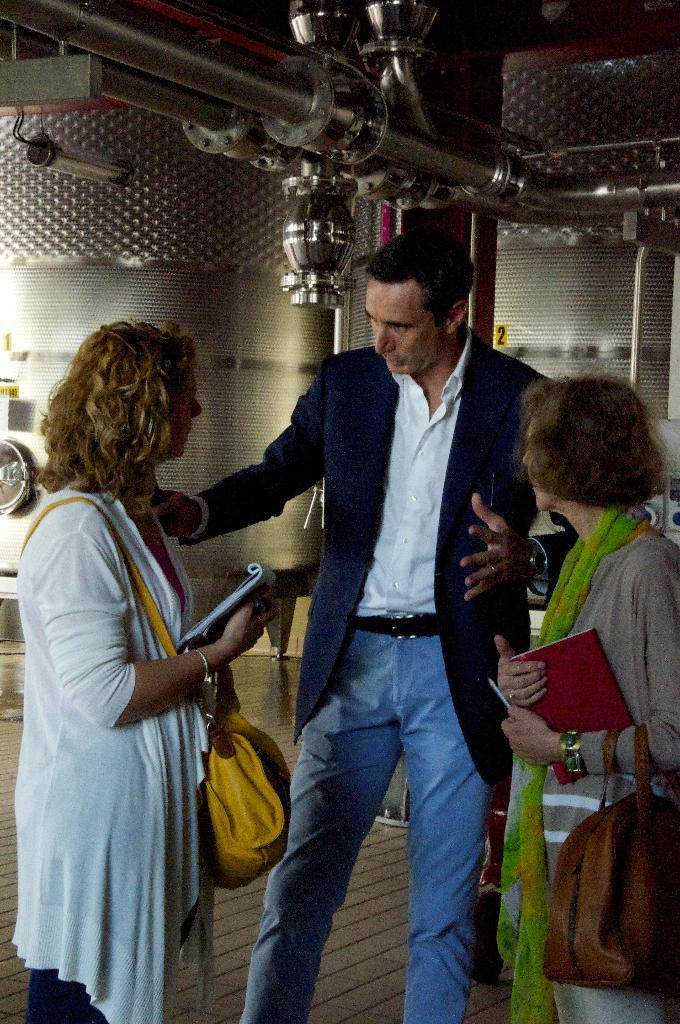How many people are present in the image? There are three people standing in the image. What is the woman holding in the image? The woman is holding a bag and a book. What can be seen in the background of the image? There is a machine and a steel pole in the background. What type of battle is taking place in the image? There is no battle present in the image; it features three people standing and a woman holding a bag and a book. Can you describe the expression of disgust on the faces of the people in the image? There is no expression of disgust visible on the faces of the people in the image. 